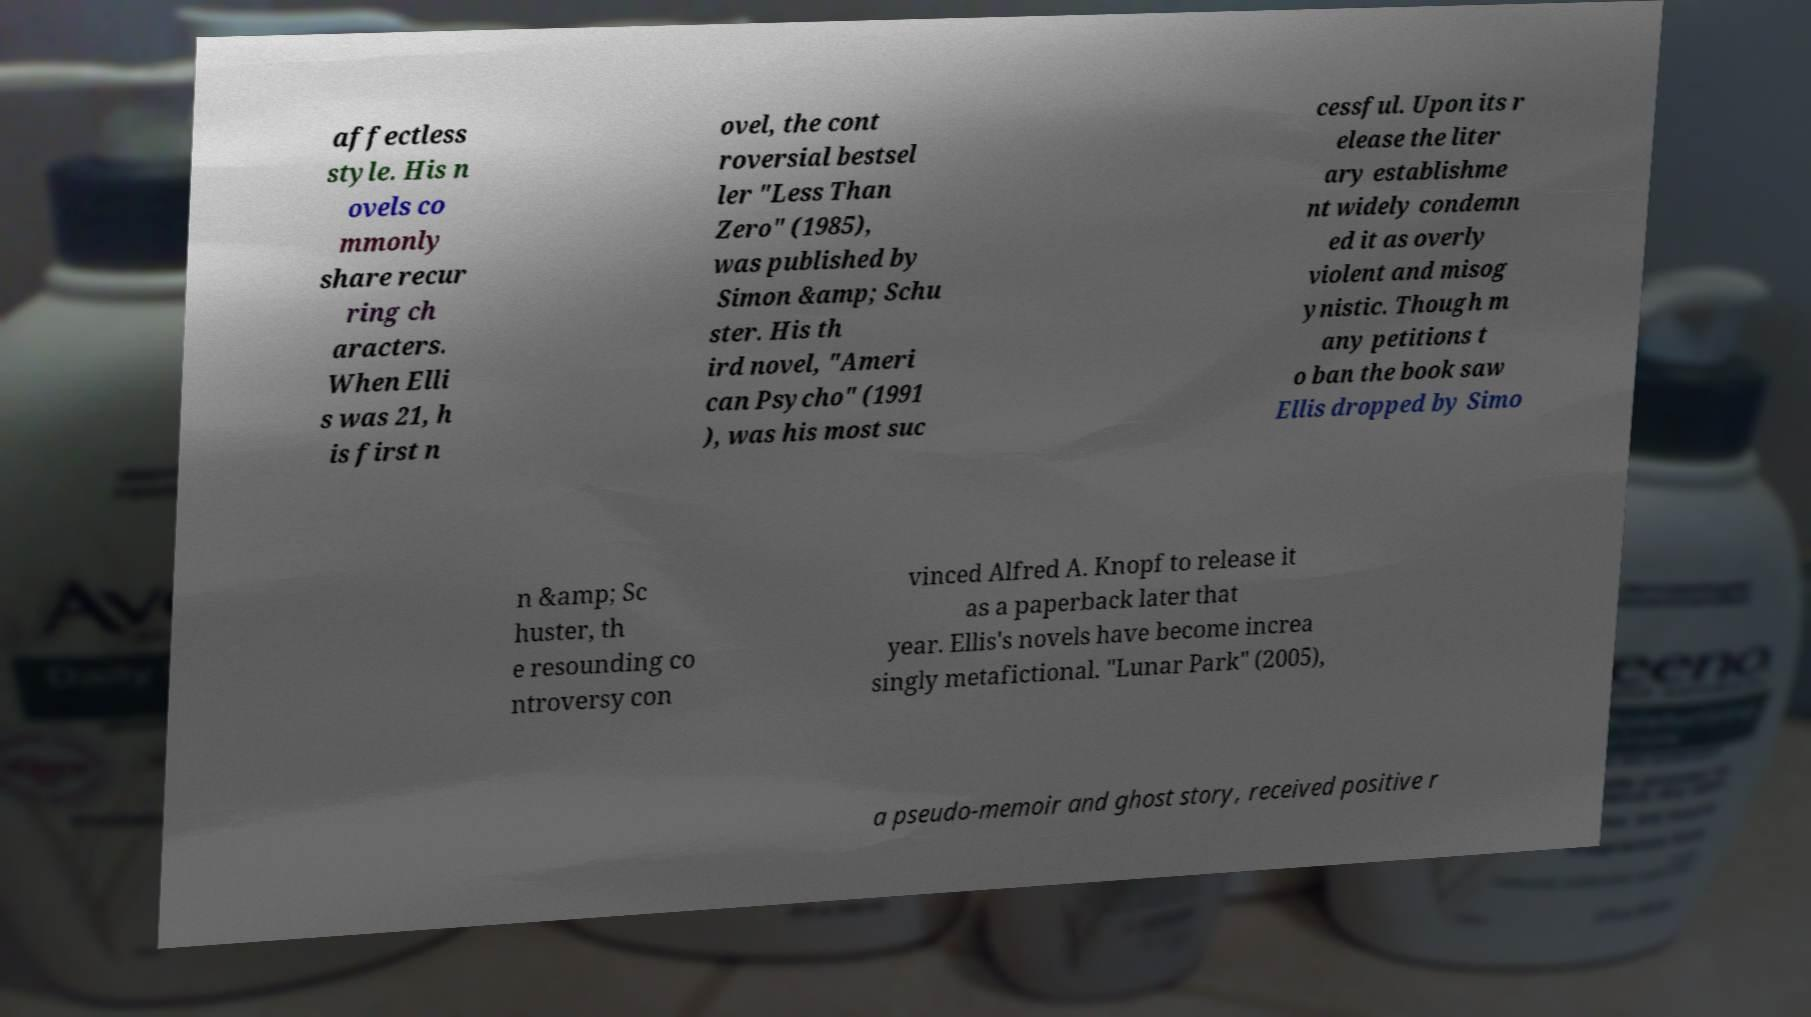Could you extract and type out the text from this image? affectless style. His n ovels co mmonly share recur ring ch aracters. When Elli s was 21, h is first n ovel, the cont roversial bestsel ler "Less Than Zero" (1985), was published by Simon &amp; Schu ster. His th ird novel, "Ameri can Psycho" (1991 ), was his most suc cessful. Upon its r elease the liter ary establishme nt widely condemn ed it as overly violent and misog ynistic. Though m any petitions t o ban the book saw Ellis dropped by Simo n &amp; Sc huster, th e resounding co ntroversy con vinced Alfred A. Knopf to release it as a paperback later that year. Ellis's novels have become increa singly metafictional. "Lunar Park" (2005), a pseudo-memoir and ghost story, received positive r 